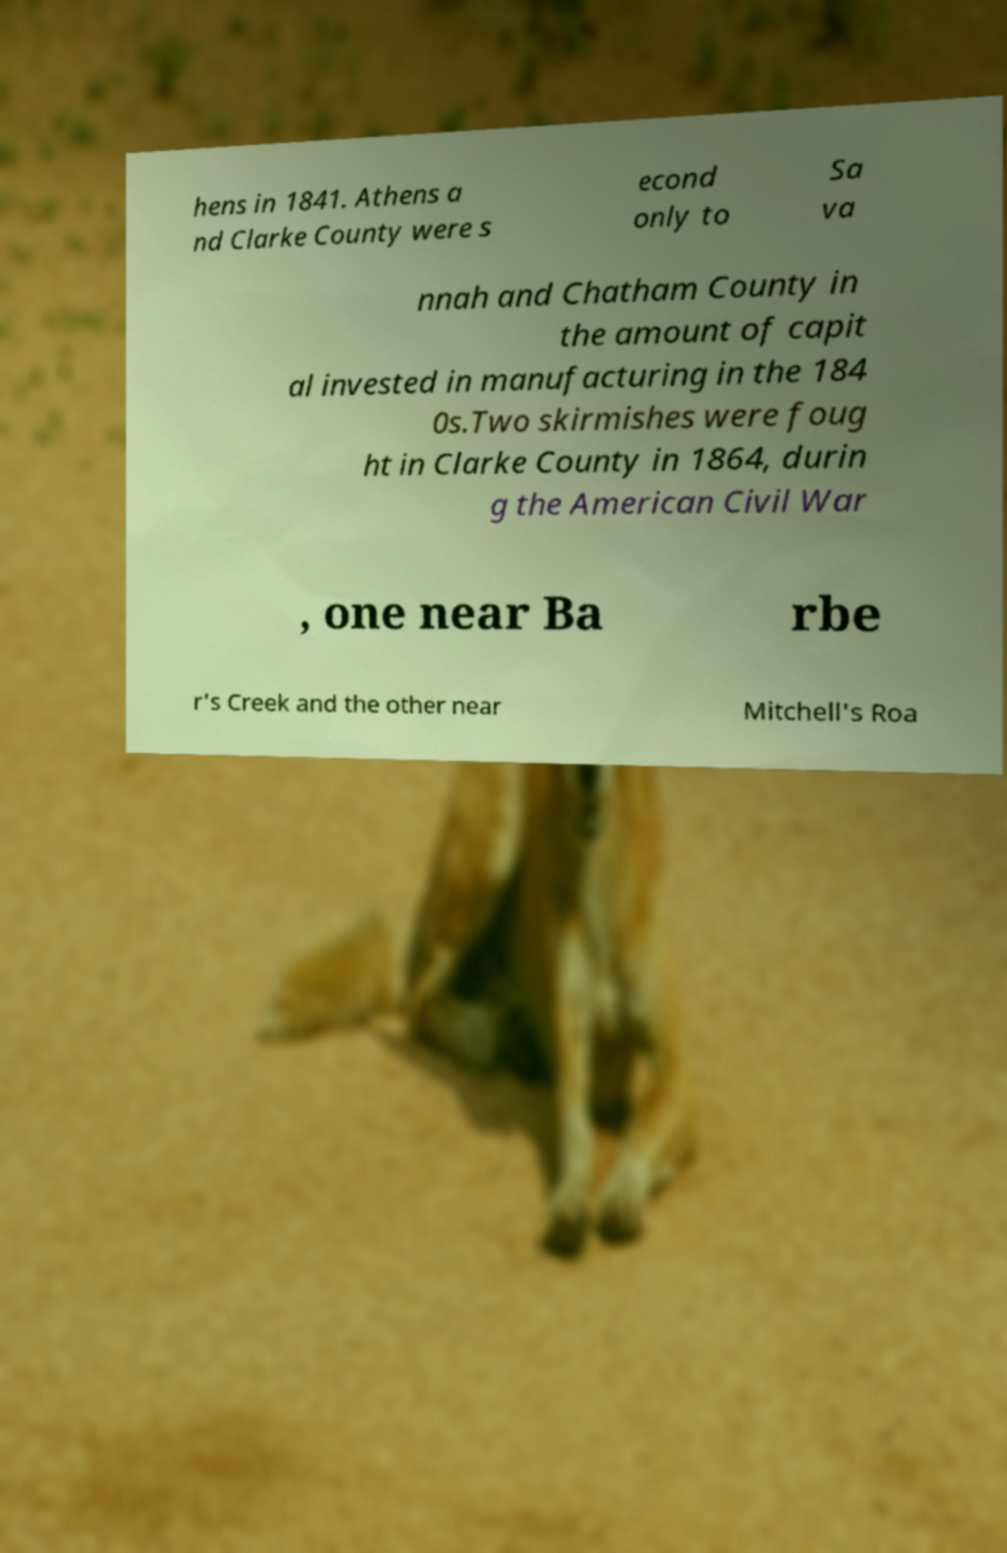I need the written content from this picture converted into text. Can you do that? hens in 1841. Athens a nd Clarke County were s econd only to Sa va nnah and Chatham County in the amount of capit al invested in manufacturing in the 184 0s.Two skirmishes were foug ht in Clarke County in 1864, durin g the American Civil War , one near Ba rbe r's Creek and the other near Mitchell's Roa 